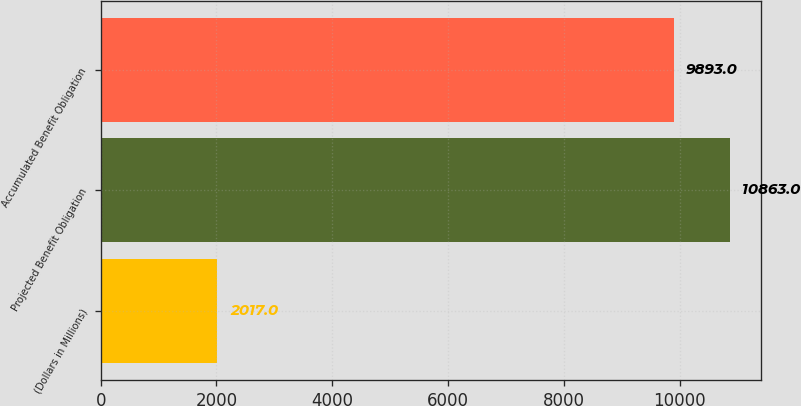<chart> <loc_0><loc_0><loc_500><loc_500><bar_chart><fcel>(Dollars in Millions)<fcel>Projected Benefit Obligation<fcel>Accumulated Benefit Obligation<nl><fcel>2017<fcel>10863<fcel>9893<nl></chart> 